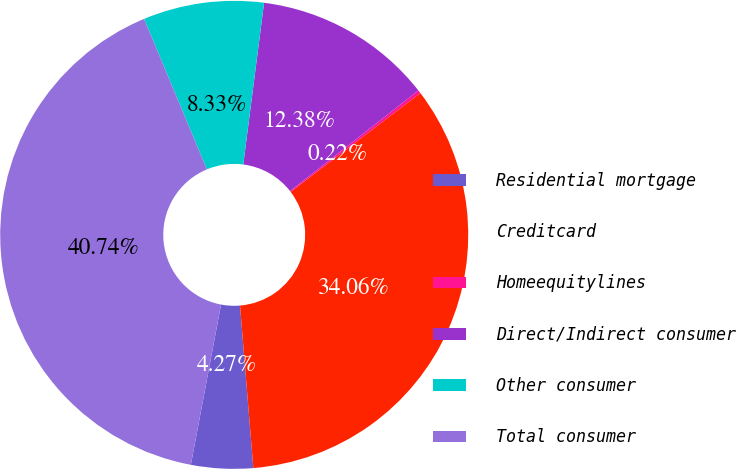Convert chart to OTSL. <chart><loc_0><loc_0><loc_500><loc_500><pie_chart><fcel>Residential mortgage<fcel>Creditcard<fcel>Homeequitylines<fcel>Direct/Indirect consumer<fcel>Other consumer<fcel>Total consumer<nl><fcel>4.27%<fcel>34.06%<fcel>0.22%<fcel>12.38%<fcel>8.33%<fcel>40.74%<nl></chart> 